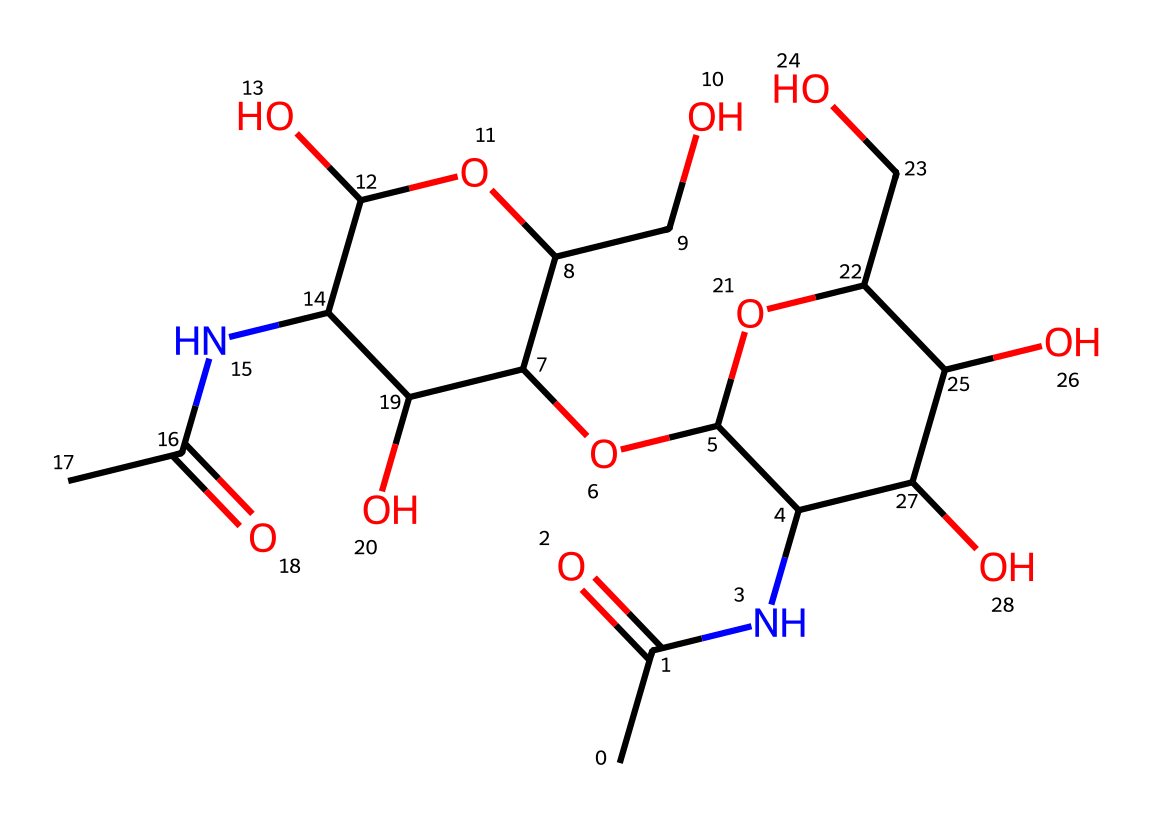How many carbon atoms are in this chemical? By counting the 'C' symbols in the SMILES representation, I find that there are 12 carbon atoms present in total.
Answer: 12 What functional groups are present in this structure? Looking at the SMILES, I can identify several functional groups such as amines (due to the nitrogen atom connected to carbon), hydroxyls (indicated by 'O' after 'C'), and acetyl groups (due to the presence of 'CC(=O)N').
Answer: amines, hydroxyls, acetyl What is the molecular weight of this chemical? To find the molecular weight, I calculate the contributions of each atom type based on the counts gathered from the SMILES: Carbon (12*12.01), Hydrogen (19*1.008), Nitrogen (2*14.01), and Oxygen (9*16.00), leading to a total molecular weight of approximately 270.3 g/mol.
Answer: 270.3 g/mol What is this chemical's primary biological function? Chitin serves primarily as structural support in the exoskeletons of insects, acting as a strong and flexible polymer.
Answer: structural support How many hydroxyl groups are present in this chemical? From the SMILES string, counting the occurrences of -OH groups (represented by 'O' connected to 'C') gives a total of 6 hydroxyl groups present in the structure.
Answer: 6 Is this chemical soluble in water? Due to the presence of multiple hydroxyl groups, which are polar, this chemical is expected to be soluble in water.
Answer: soluble in water 